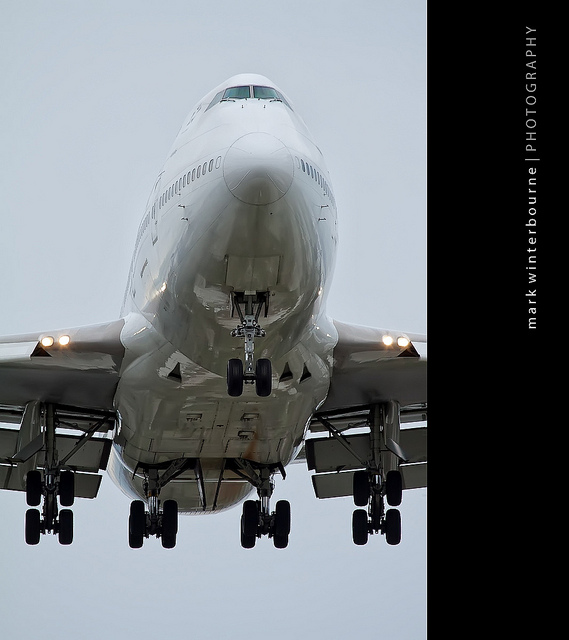Identify and read out the text in this image. mark winterbourne PHOTOGRAPHY 